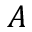<formula> <loc_0><loc_0><loc_500><loc_500>A</formula> 